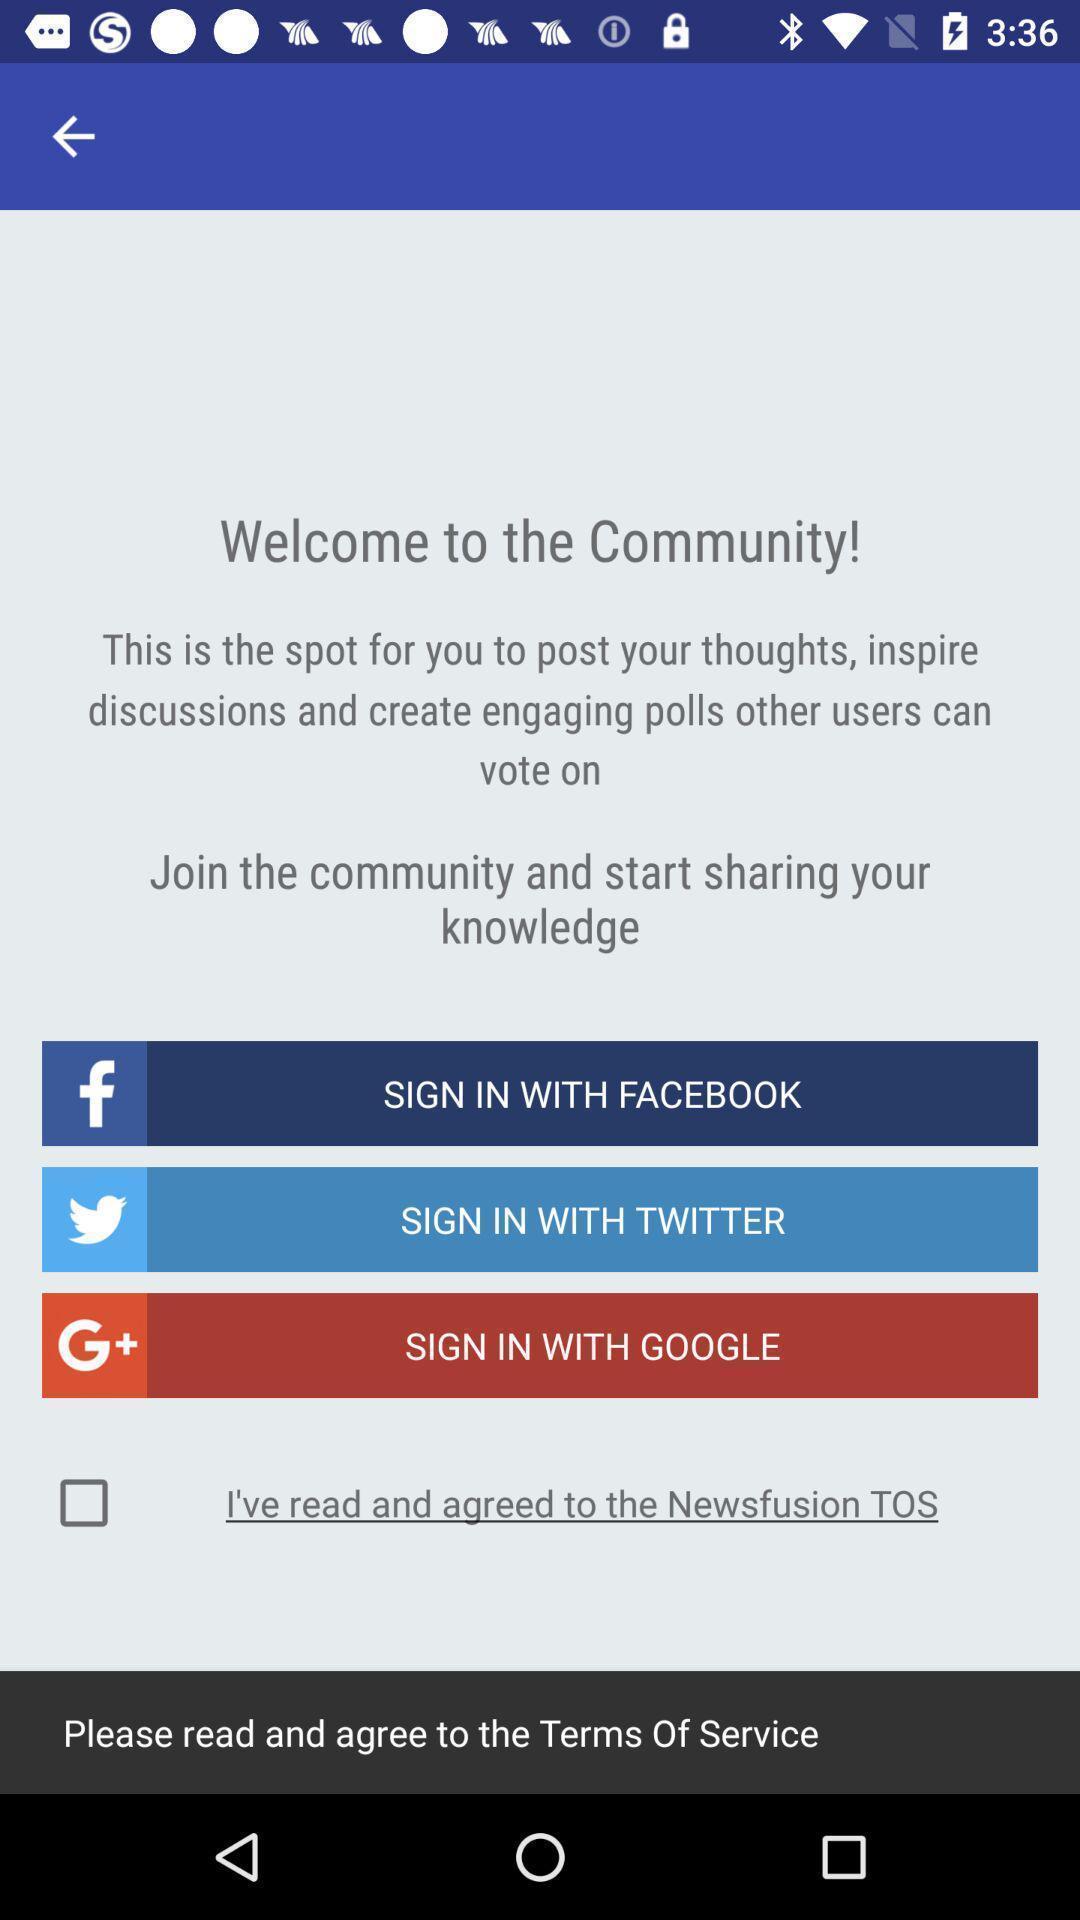Summarize the main components in this picture. Welcome page. 